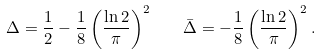Convert formula to latex. <formula><loc_0><loc_0><loc_500><loc_500>\Delta = \frac { 1 } 2 - \frac { 1 } 8 \left ( \frac { \ln 2 } \pi \right ) ^ { 2 } \quad \bar { \Delta } = - \frac { 1 } { 8 } \left ( \frac { \ln 2 } { \pi } \right ) ^ { 2 } .</formula> 